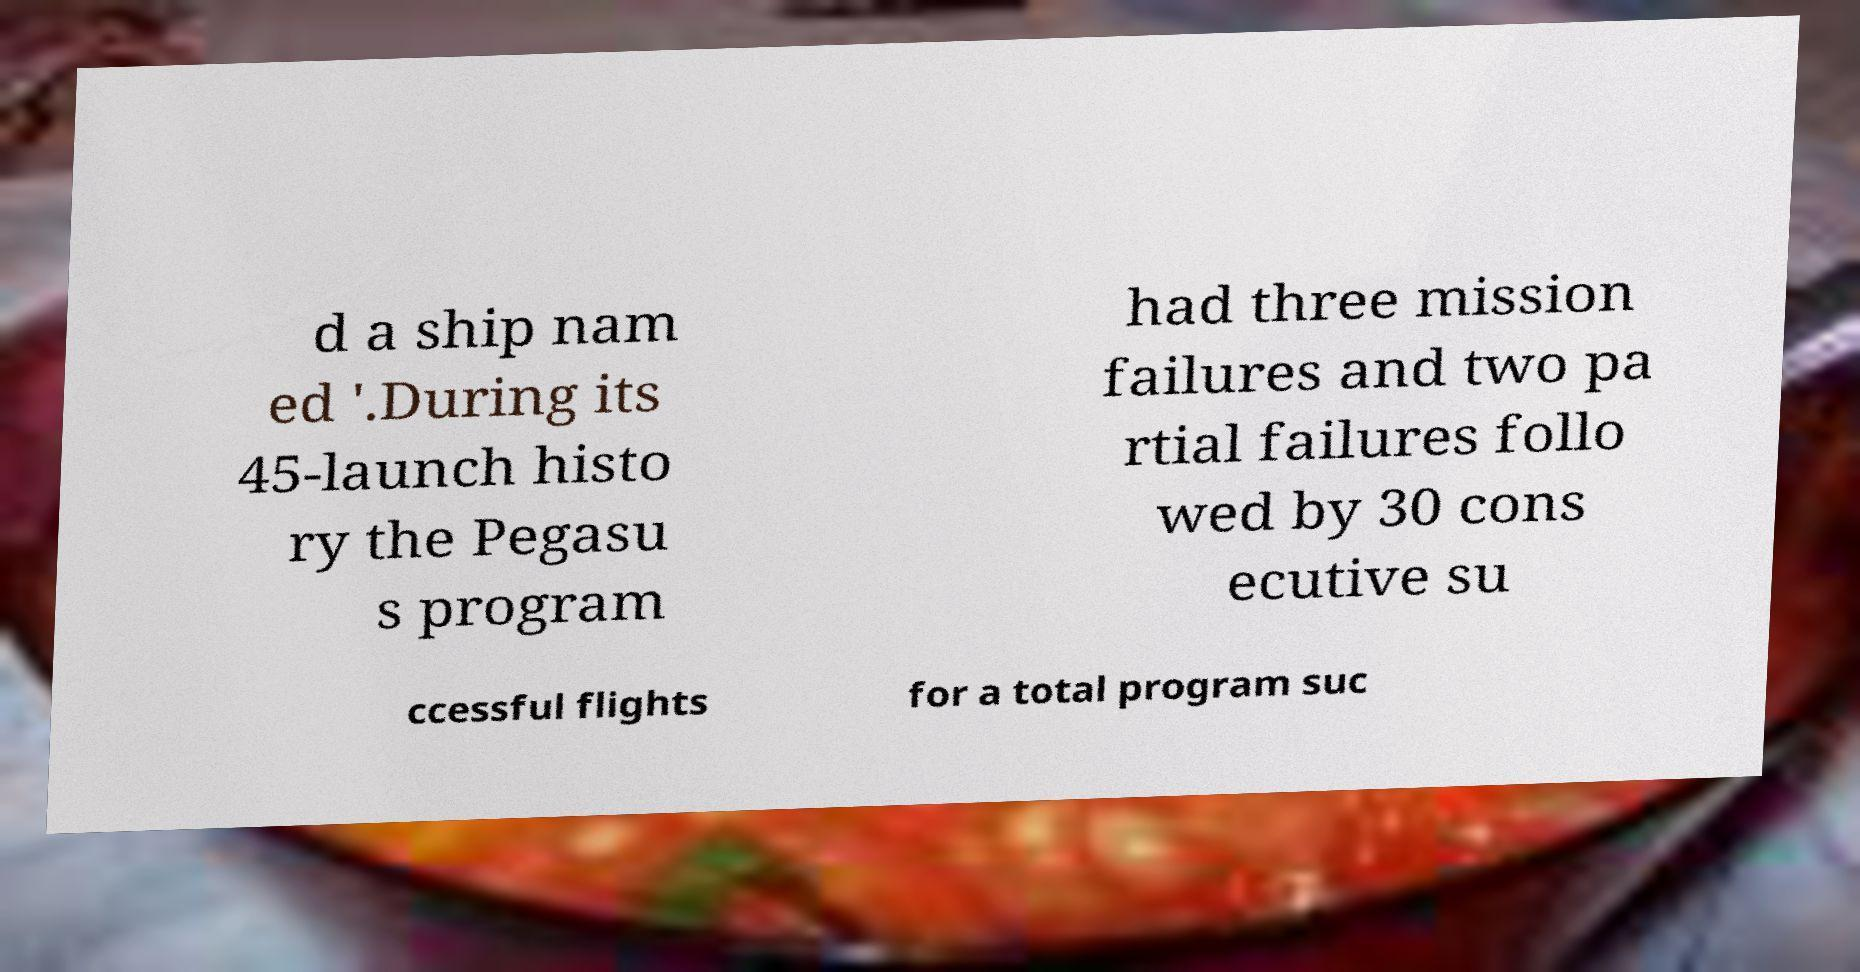There's text embedded in this image that I need extracted. Can you transcribe it verbatim? d a ship nam ed '.During its 45-launch histo ry the Pegasu s program had three mission failures and two pa rtial failures follo wed by 30 cons ecutive su ccessful flights for a total program suc 